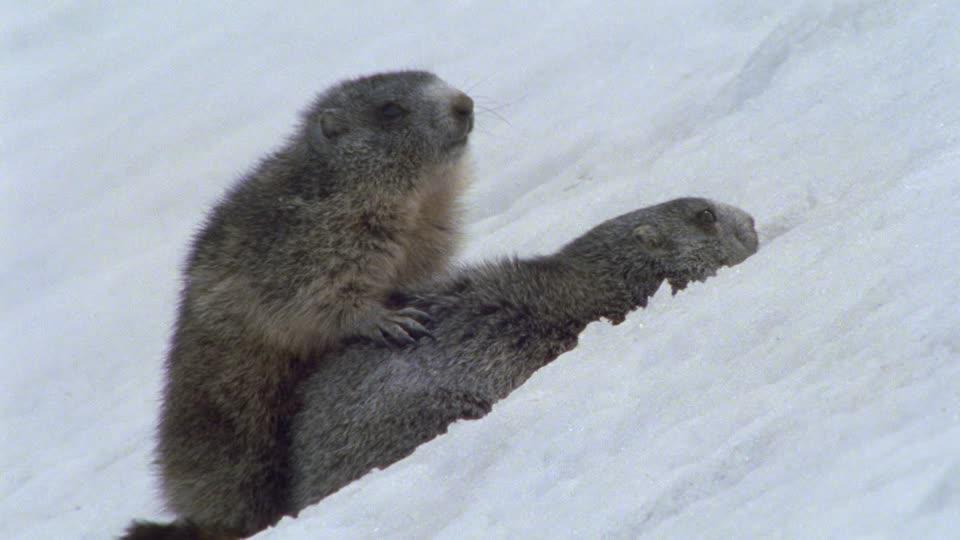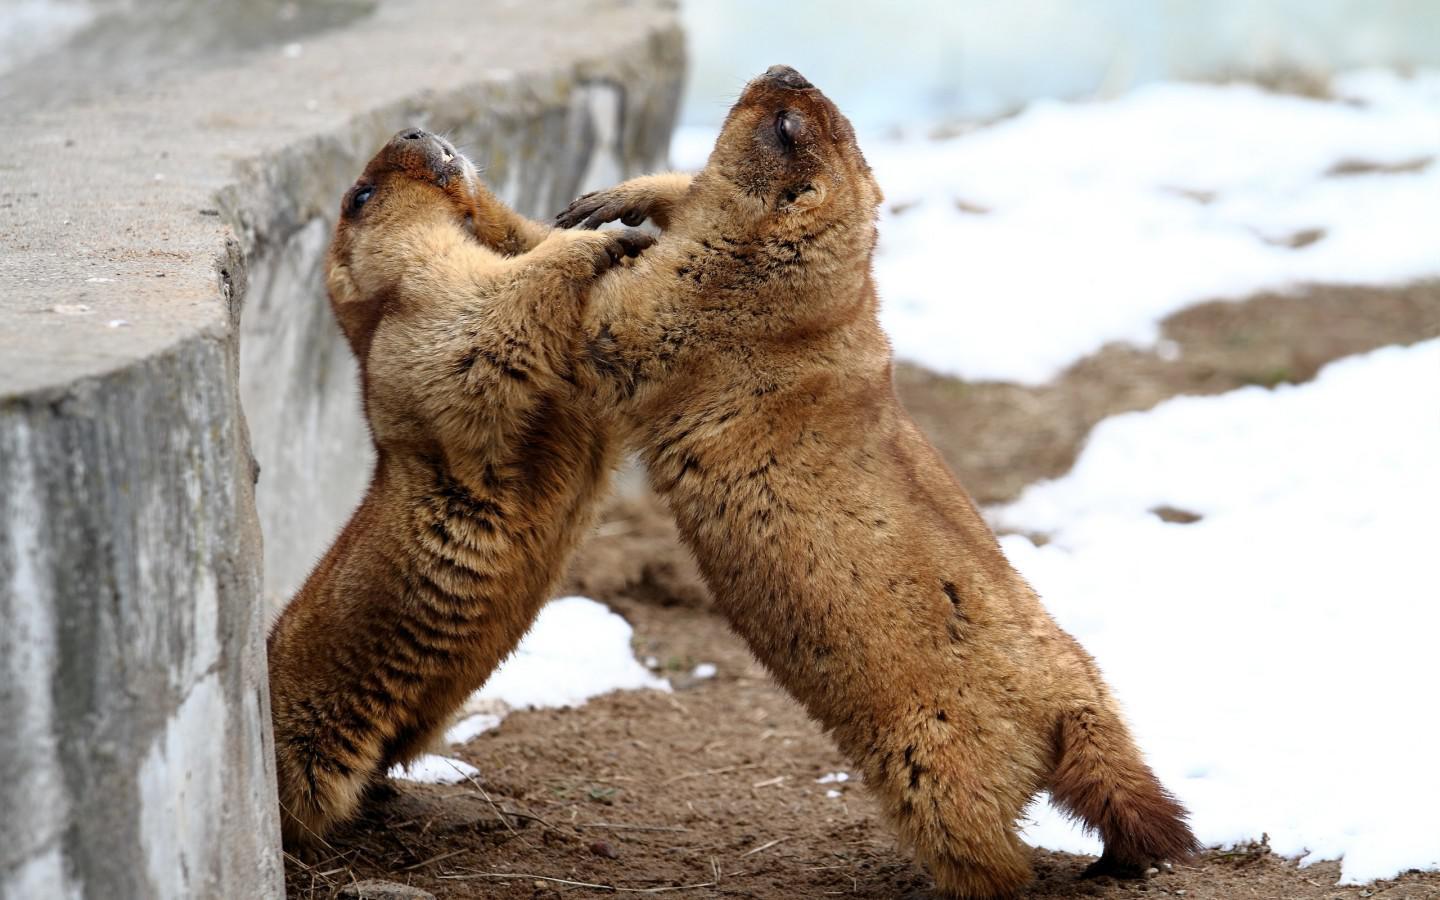The first image is the image on the left, the second image is the image on the right. Given the left and right images, does the statement "There are 4 prairie dogs and 2 are up on their hind legs." hold true? Answer yes or no. Yes. The first image is the image on the left, the second image is the image on the right. Examine the images to the left and right. Is the description "There are at least 1 woodchuck poking its head out of the snow." accurate? Answer yes or no. No. 